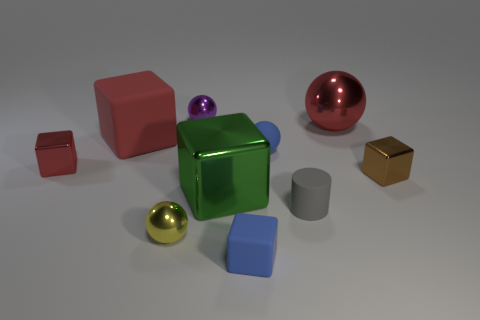Subtract all large metal cubes. How many cubes are left? 4 Subtract all purple balls. How many balls are left? 3 Subtract all spheres. How many objects are left? 6 Subtract 3 blocks. How many blocks are left? 2 Subtract all green balls. Subtract all red cylinders. How many balls are left? 4 Subtract all cyan cubes. How many blue spheres are left? 1 Subtract all tiny blue metallic cylinders. Subtract all metallic cubes. How many objects are left? 7 Add 8 gray cylinders. How many gray cylinders are left? 9 Add 7 big gray metal cylinders. How many big gray metal cylinders exist? 7 Subtract 0 red cylinders. How many objects are left? 10 